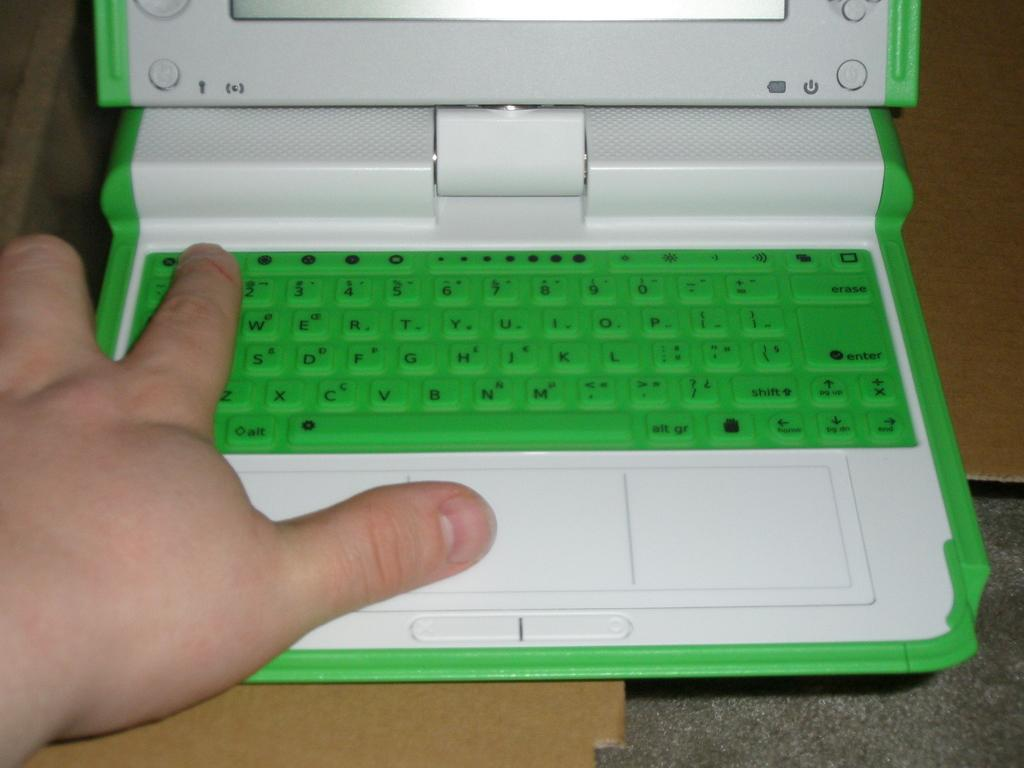<image>
Give a short and clear explanation of the subsequent image. Someone is using their index finger to press the number 1 key on a green and white laptop's keyboard. 